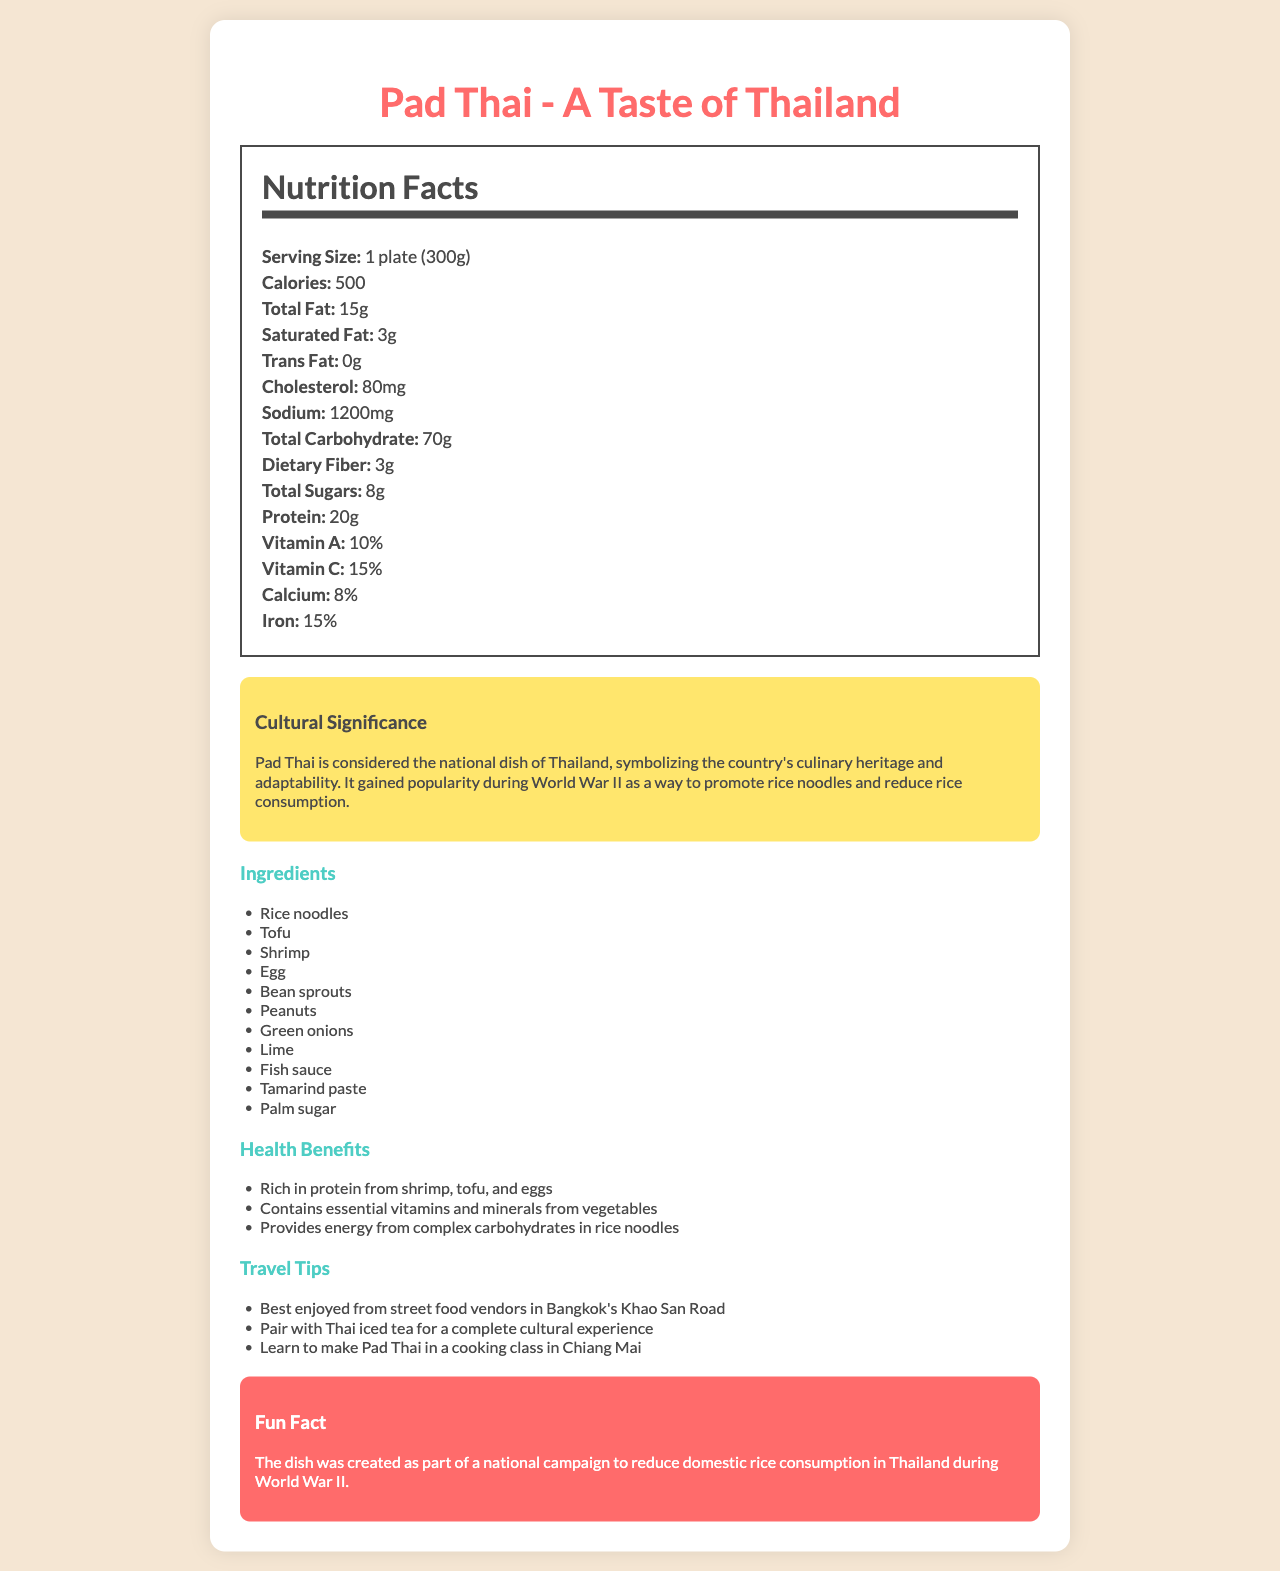what is the serving size for Pad Thai? The serving size is clearly mentioned as 1 plate (300g) in the Nutrition Facts section.
Answer: 1 plate (300g) How many calories are in a serving of Pad Thai? The document specifies that a serving of Pad Thai contains 500 calories.
Answer: 500 What is the total fat content in one plate of Pad Thai? The Nutrition Facts indicate that the total fat content in one plate of Pad Thai is 15 grams.
Answer: 15g List three main ingredients in Pad Thai. The Ingredients list specifies several components, including rice noodles, tofu, and shrimp.
Answer: Rice noodles, Tofu, Shrimp Is the trans fat content in Pad Thai significant? The document states that the trans fat content is 0 grams, which is not significant.
Answer: No How much sodium does a serving of Pad Thai contain? The sodium content is listed as 1200 milligrams in the Nutrition Facts section.
Answer: 1200mg What is the cholesterol content in Pad Thai? A. 50mg B. 80mg C. 100mg D. 120mg The document lists the cholesterol content as 80 milligrams.
Answer: B Which of the following is NOT listed as an ingredient in Pad Thai? I. Lime II. Broccoli III. Peanuts IV. Fish sauce Broccoli is not listed as an ingredient. The other options are all included in the Ingredients list.
Answer: II Is Pad Thai a good source of Vitamin A? The document states that Pad Thai contains 10% of the daily recommended value of Vitamin A.
Answer: Yes Summarize the main cultural significance of Pad Thai. The document explains Pad Thai's cultural significance in a section dedicated to it, emphasizing its role during World War II and its place in Thai culture.
Answer: Pad Thai is considered the national dish of Thailand and symbolizes the country's culinary heritage and adaptability. It became popular during World War II to promote rice noodles and reduce rice consumption. Explain one health benefit of Pad Thai. The Health Benefits section states that Pad Thai is rich in protein due to its ingredients, which include shrimp, tofu, and eggs.
Answer: Rich in protein from shrimp, tofu, and eggs Where can you best experience Pad Thai? The Travel Tips section recommends experiencing Pad Thai from street food vendors on Bangkok's Khao San Road.
Answer: Best enjoyed from street food vendors in Bangkok's Khao San Road How much vitamin C is in a serving of Pad Thai? The Nutrition Facts section lists the vitamin C content as 15% of the daily recommended value.
Answer: 15% What was Pad Thai created as part of? The Fun Fact section mentions that Pad Thai was created as part of this national campaign.
Answer: A national campaign to reduce domestic rice consumption in Thailand during World War II What type of cooking class can you take in Chiang Mai related to Pad Thai? The Travel Tips section lists taking a cooking class in Chiang Mai to learn how to make Pad Thai.
Answer: Learn to make Pad Thai Does the document mention the fiber content in Pad Thai? The document states that Pad Thai contains 3 grams of dietary fiber.
Answer: Yes How much protein is in a serving of Pad Thai? The Nutrition Facts indicate that there are 20 grams of protein in a serving.
Answer: 20g What percentage of calcium is provided by Pad Thai? The Nutrition Facts section specifies that Pad Thai contains 8% of the daily recommended value of calcium.
Answer: 8% What is the primary source of energy in Pad Thai? The Health Benefits section mentions that rice noodles, which are complex carbohydrates, provide the energy.
Answer: Provides energy from complex carbohydrates in rice noodles How long has Pad Thai been promoted as a national dish of Thailand? The document does not specify the exact duration for which Pad Thai has been promoted as a national dish.
Answer: Not enough information 